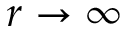<formula> <loc_0><loc_0><loc_500><loc_500>r \rightarrow \infty</formula> 